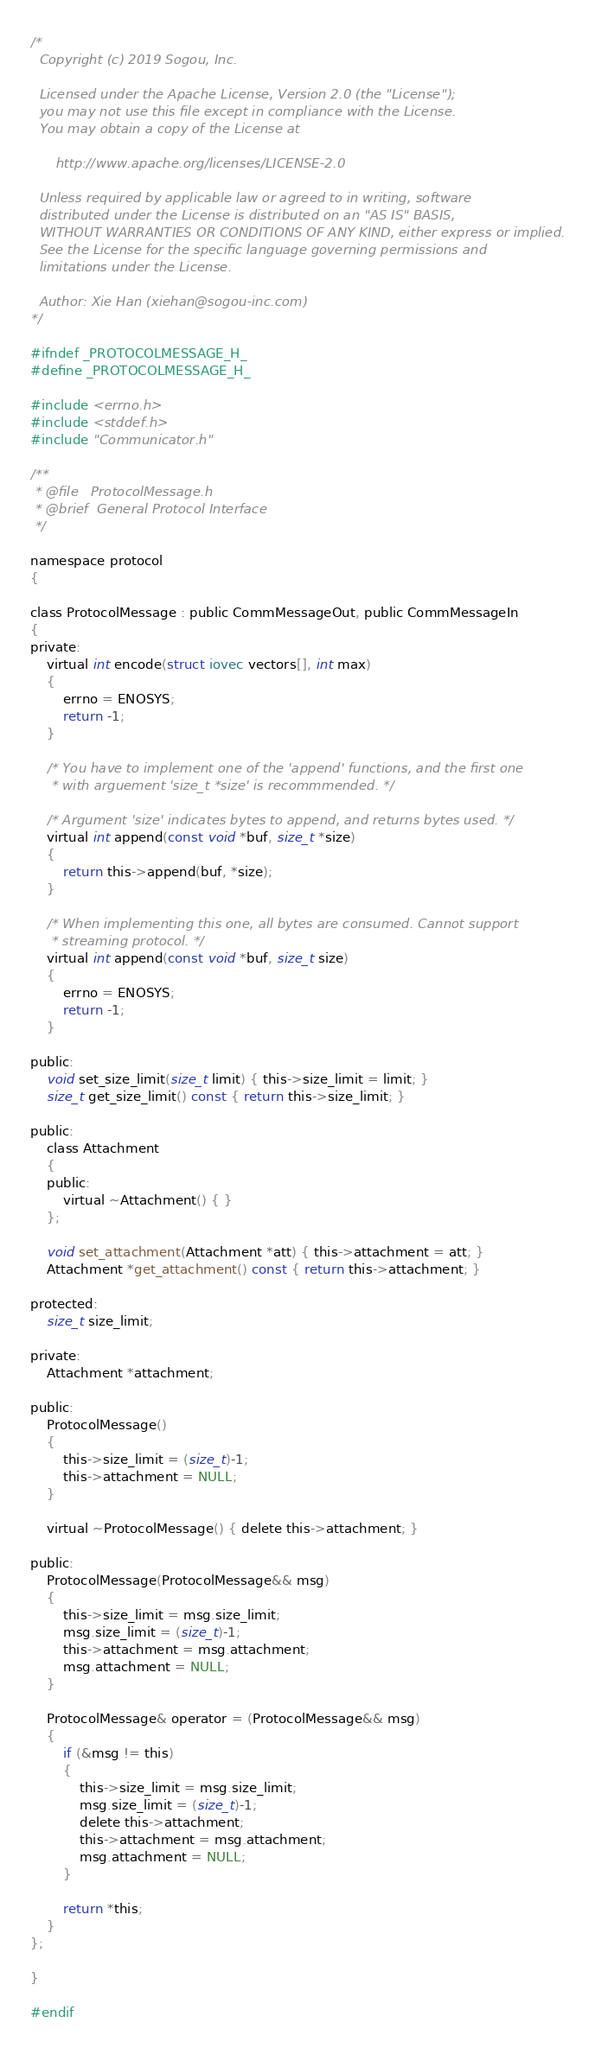Convert code to text. <code><loc_0><loc_0><loc_500><loc_500><_C_>/*
  Copyright (c) 2019 Sogou, Inc.

  Licensed under the Apache License, Version 2.0 (the "License");
  you may not use this file except in compliance with the License.
  You may obtain a copy of the License at

      http://www.apache.org/licenses/LICENSE-2.0

  Unless required by applicable law or agreed to in writing, software
  distributed under the License is distributed on an "AS IS" BASIS,
  WITHOUT WARRANTIES OR CONDITIONS OF ANY KIND, either express or implied.
  See the License for the specific language governing permissions and
  limitations under the License.

  Author: Xie Han (xiehan@sogou-inc.com)
*/

#ifndef _PROTOCOLMESSAGE_H_
#define _PROTOCOLMESSAGE_H_

#include <errno.h>
#include <stddef.h>
#include "Communicator.h"

/**
 * @file   ProtocolMessage.h
 * @brief  General Protocol Interface
 */

namespace protocol
{

class ProtocolMessage : public CommMessageOut, public CommMessageIn
{
private:
	virtual int encode(struct iovec vectors[], int max)
	{
		errno = ENOSYS;
		return -1;
	}

	/* You have to implement one of the 'append' functions, and the first one
	 * with arguement 'size_t *size' is recommmended. */

	/* Argument 'size' indicates bytes to append, and returns bytes used. */
	virtual int append(const void *buf, size_t *size)
	{
		return this->append(buf, *size);
	}

	/* When implementing this one, all bytes are consumed. Cannot support
	 * streaming protocol. */
	virtual int append(const void *buf, size_t size)
	{
		errno = ENOSYS;
		return -1;
	}

public:
	void set_size_limit(size_t limit) { this->size_limit = limit; }
	size_t get_size_limit() const { return this->size_limit; }

public:
	class Attachment
	{
	public:
		virtual ~Attachment() { }
	};

	void set_attachment(Attachment *att) { this->attachment = att; }
	Attachment *get_attachment() const { return this->attachment; }

protected:
	size_t size_limit;

private:
	Attachment *attachment;

public:
	ProtocolMessage()
	{
		this->size_limit = (size_t)-1;
		this->attachment = NULL;
	}

	virtual ~ProtocolMessage() { delete this->attachment; }

public:
	ProtocolMessage(ProtocolMessage&& msg)
	{
		this->size_limit = msg.size_limit;
		msg.size_limit = (size_t)-1;
		this->attachment = msg.attachment;
		msg.attachment = NULL;
	}

	ProtocolMessage& operator = (ProtocolMessage&& msg)
	{
		if (&msg != this)
		{
			this->size_limit = msg.size_limit;
			msg.size_limit = (size_t)-1;
			delete this->attachment;
			this->attachment = msg.attachment;
			msg.attachment = NULL;
		}

		return *this;
	}
};

}

#endif

</code> 